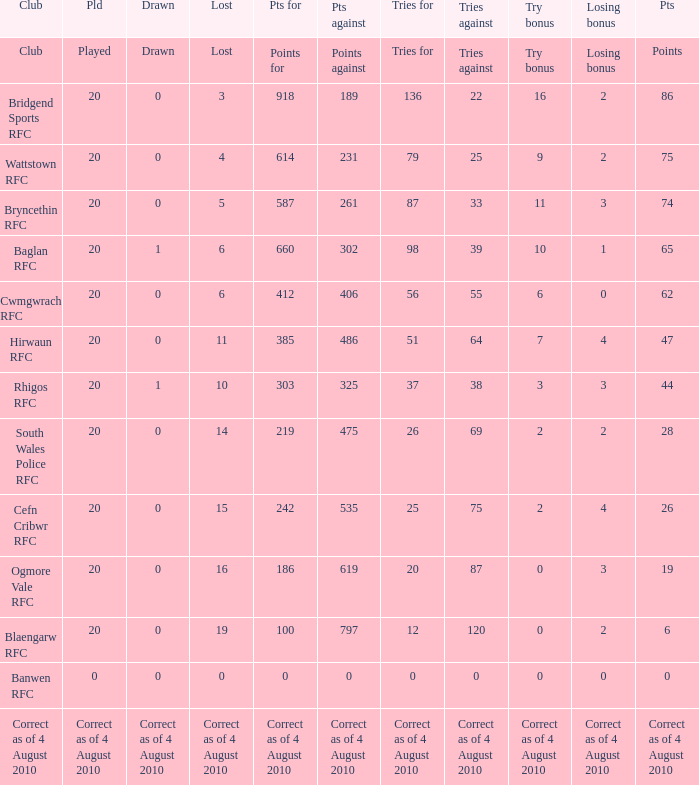What is the points when the club blaengarw rfc? 6.0. 